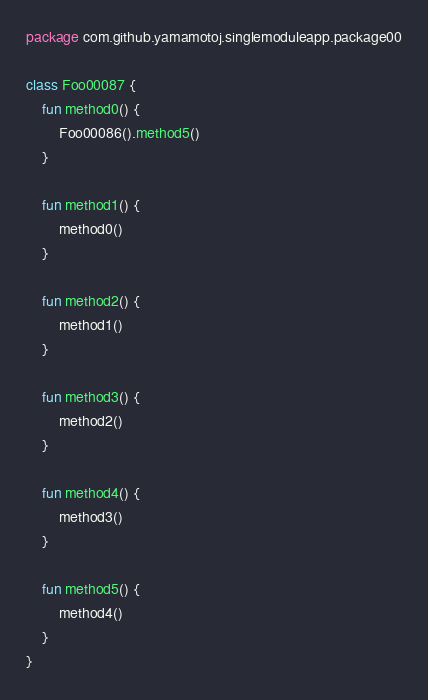Convert code to text. <code><loc_0><loc_0><loc_500><loc_500><_Kotlin_>package com.github.yamamotoj.singlemoduleapp.package00

class Foo00087 {
    fun method0() {
        Foo00086().method5()
    }

    fun method1() {
        method0()
    }

    fun method2() {
        method1()
    }

    fun method3() {
        method2()
    }

    fun method4() {
        method3()
    }

    fun method5() {
        method4()
    }
}
</code> 